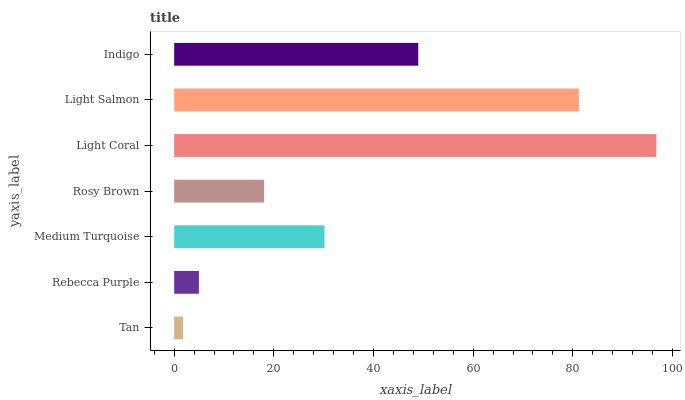Is Tan the minimum?
Answer yes or no. Yes. Is Light Coral the maximum?
Answer yes or no. Yes. Is Rebecca Purple the minimum?
Answer yes or no. No. Is Rebecca Purple the maximum?
Answer yes or no. No. Is Rebecca Purple greater than Tan?
Answer yes or no. Yes. Is Tan less than Rebecca Purple?
Answer yes or no. Yes. Is Tan greater than Rebecca Purple?
Answer yes or no. No. Is Rebecca Purple less than Tan?
Answer yes or no. No. Is Medium Turquoise the high median?
Answer yes or no. Yes. Is Medium Turquoise the low median?
Answer yes or no. Yes. Is Light Salmon the high median?
Answer yes or no. No. Is Rosy Brown the low median?
Answer yes or no. No. 